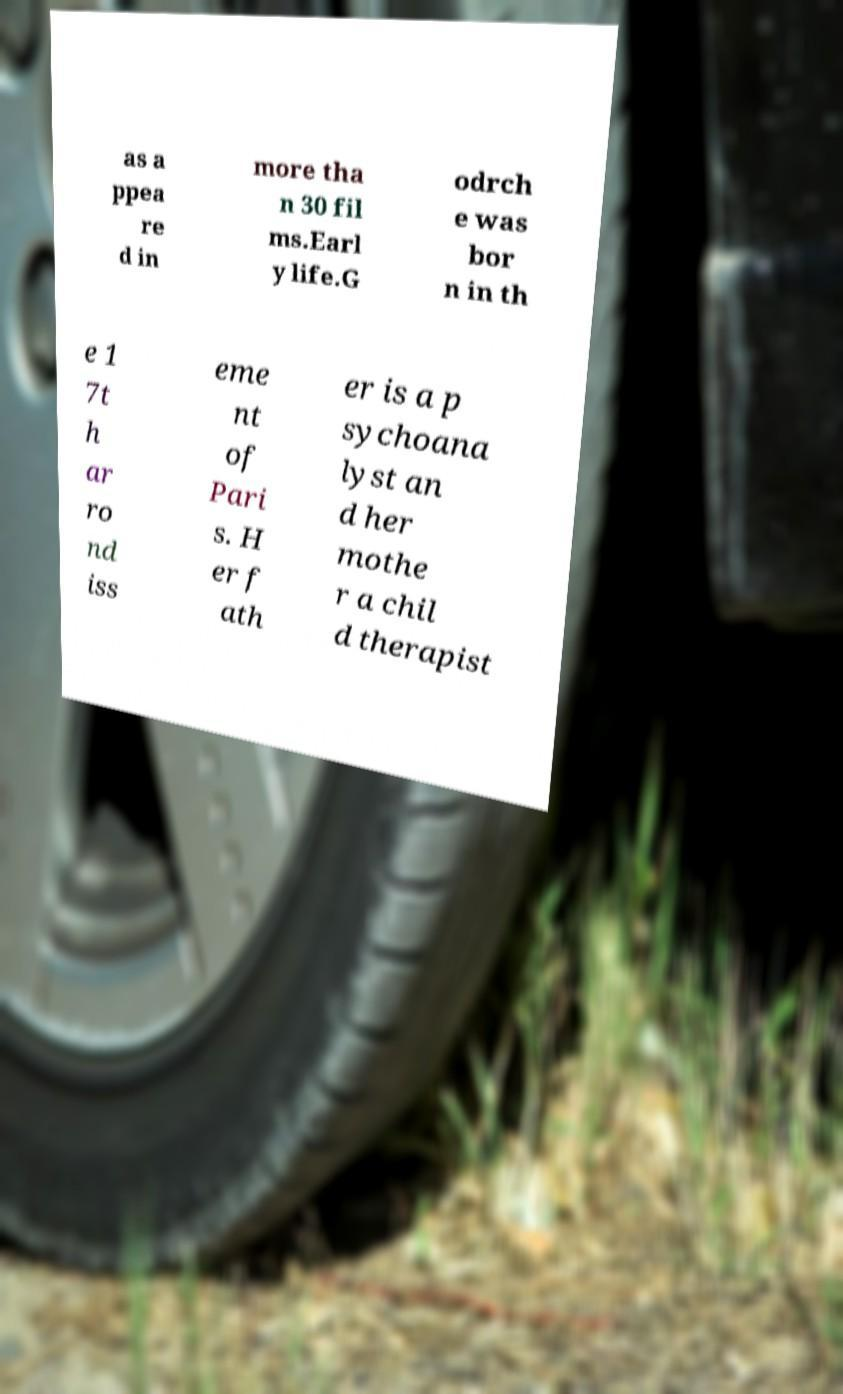I need the written content from this picture converted into text. Can you do that? as a ppea re d in more tha n 30 fil ms.Earl y life.G odrch e was bor n in th e 1 7t h ar ro nd iss eme nt of Pari s. H er f ath er is a p sychoana lyst an d her mothe r a chil d therapist 